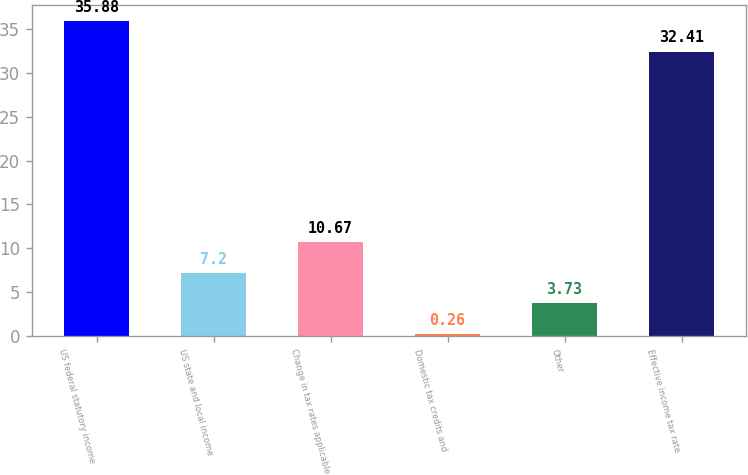<chart> <loc_0><loc_0><loc_500><loc_500><bar_chart><fcel>US federal statutory income<fcel>US state and local income<fcel>Change in tax rates applicable<fcel>Domestic tax credits and<fcel>Other<fcel>Effective income tax rate<nl><fcel>35.88<fcel>7.2<fcel>10.67<fcel>0.26<fcel>3.73<fcel>32.41<nl></chart> 